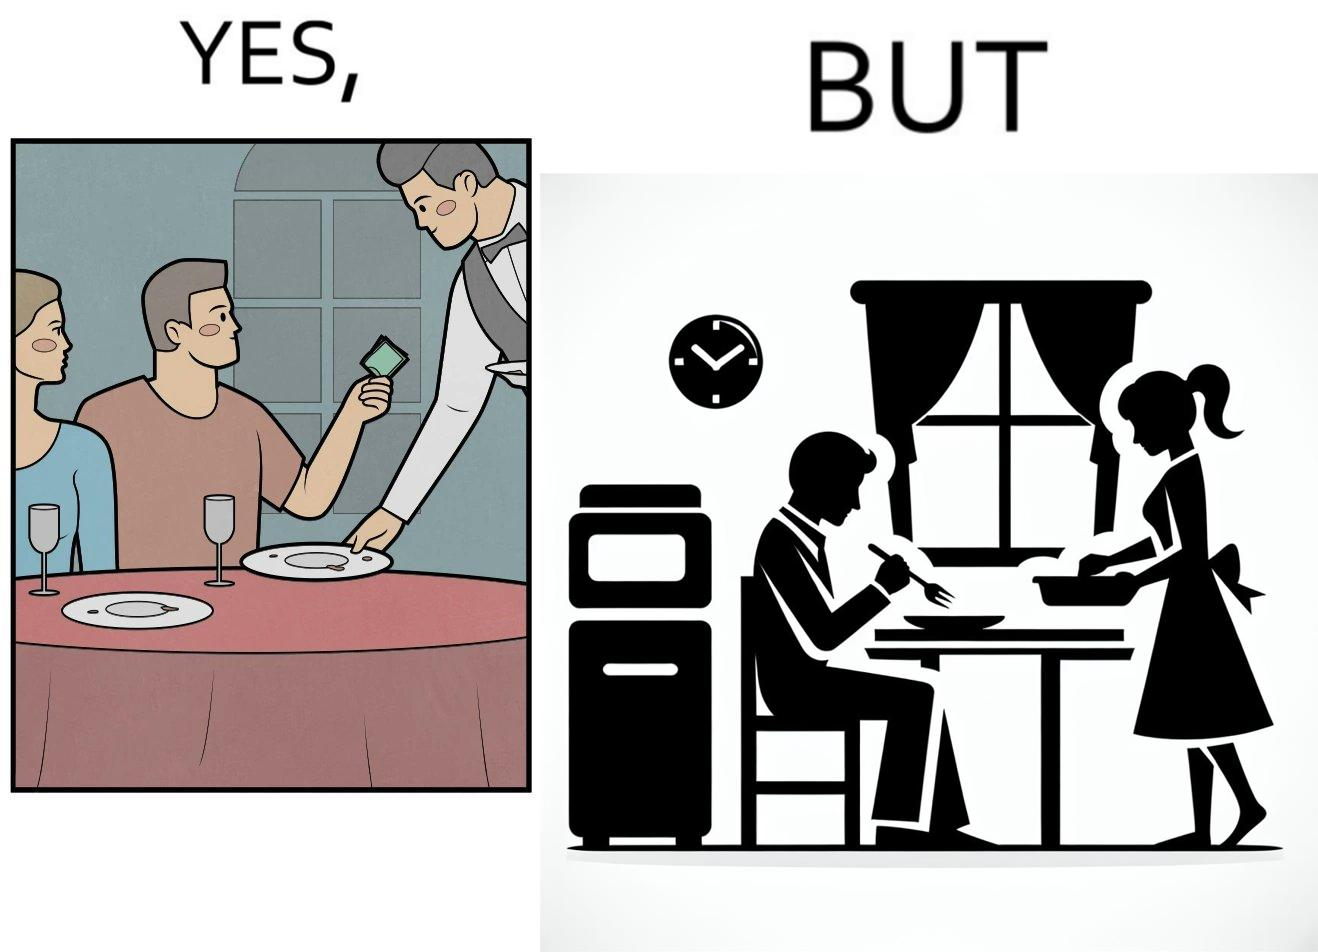Explain why this image is satirical. The image is ironical, as a man tips the waiter at a restaurant for the meal, but seems to not even acknowledge when his wife has made the meal for him at home. 